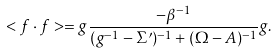Convert formula to latex. <formula><loc_0><loc_0><loc_500><loc_500>< f \cdot f > = g \frac { - \beta ^ { - 1 } } { ( g ^ { - 1 } - \Sigma ^ { \prime } ) ^ { - 1 } + ( \Omega - A ) ^ { - 1 } } g .</formula> 